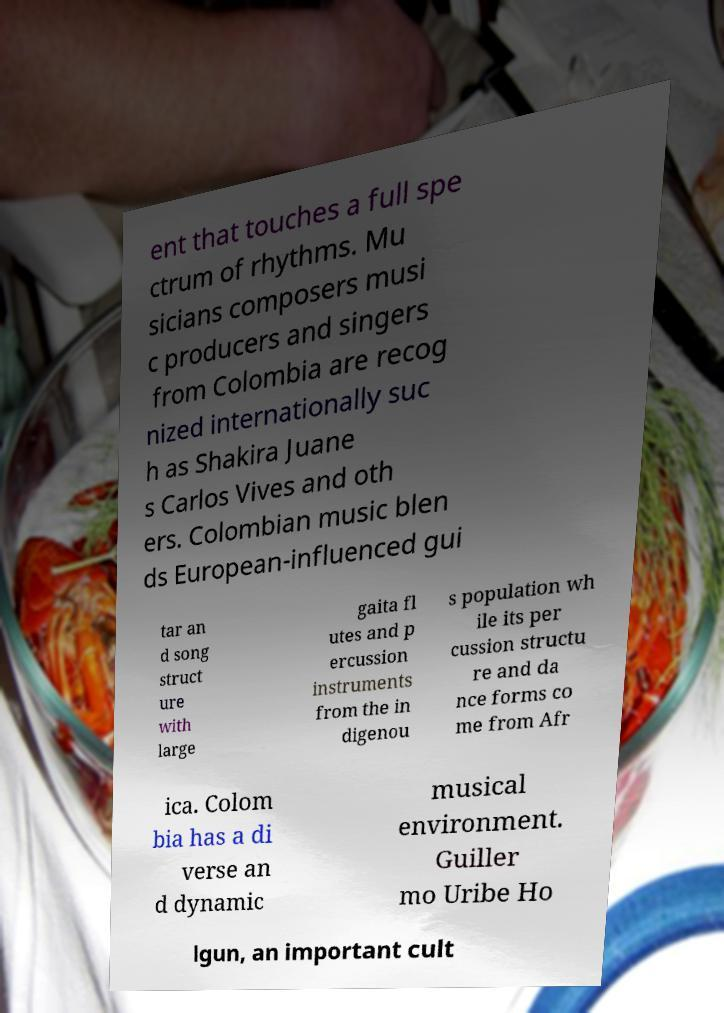Could you extract and type out the text from this image? ent that touches a full spe ctrum of rhythms. Mu sicians composers musi c producers and singers from Colombia are recog nized internationally suc h as Shakira Juane s Carlos Vives and oth ers. Colombian music blen ds European-influenced gui tar an d song struct ure with large gaita fl utes and p ercussion instruments from the in digenou s population wh ile its per cussion structu re and da nce forms co me from Afr ica. Colom bia has a di verse an d dynamic musical environment. Guiller mo Uribe Ho lgun, an important cult 